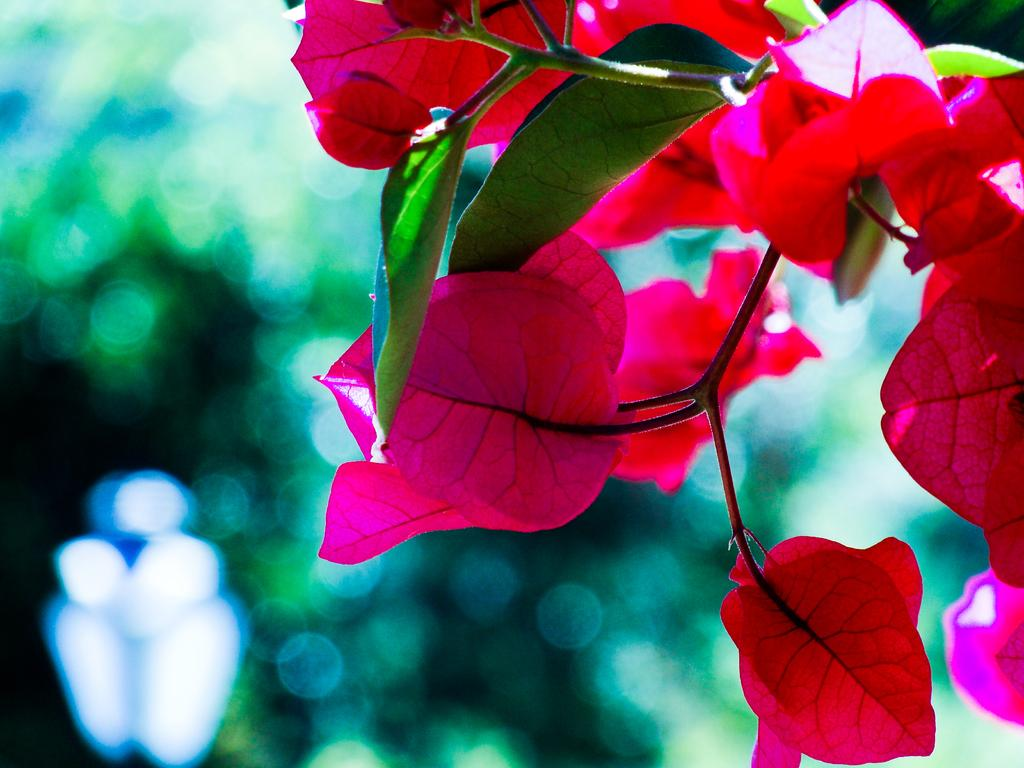What type of plant is in the image? The plant in the image has pink leaves. What color are the leaves in the middle of the image? The leaves in the middle of the image are green. How would you describe the background of the image? The background of the image is blurred. Where is the shelf located in the image? There is no shelf present in the image. What is the plant's afterthought about the color of its leaves? The plant's afterthought about the color of its leaves is not relevant, as the plant's leaves are already a specific color (pink). 